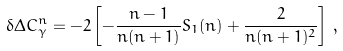<formula> <loc_0><loc_0><loc_500><loc_500>\delta \Delta C _ { \gamma } ^ { n } = - 2 \left [ - \frac { n - 1 } { n ( n + 1 ) } S _ { 1 } ( n ) + \frac { 2 } { n ( n + 1 ) ^ { 2 } } \right ] \, ,</formula> 